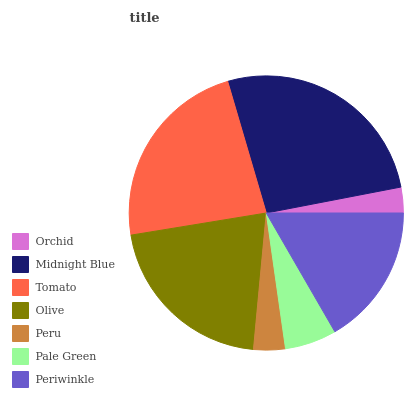Is Orchid the minimum?
Answer yes or no. Yes. Is Midnight Blue the maximum?
Answer yes or no. Yes. Is Tomato the minimum?
Answer yes or no. No. Is Tomato the maximum?
Answer yes or no. No. Is Midnight Blue greater than Tomato?
Answer yes or no. Yes. Is Tomato less than Midnight Blue?
Answer yes or no. Yes. Is Tomato greater than Midnight Blue?
Answer yes or no. No. Is Midnight Blue less than Tomato?
Answer yes or no. No. Is Periwinkle the high median?
Answer yes or no. Yes. Is Periwinkle the low median?
Answer yes or no. Yes. Is Pale Green the high median?
Answer yes or no. No. Is Midnight Blue the low median?
Answer yes or no. No. 